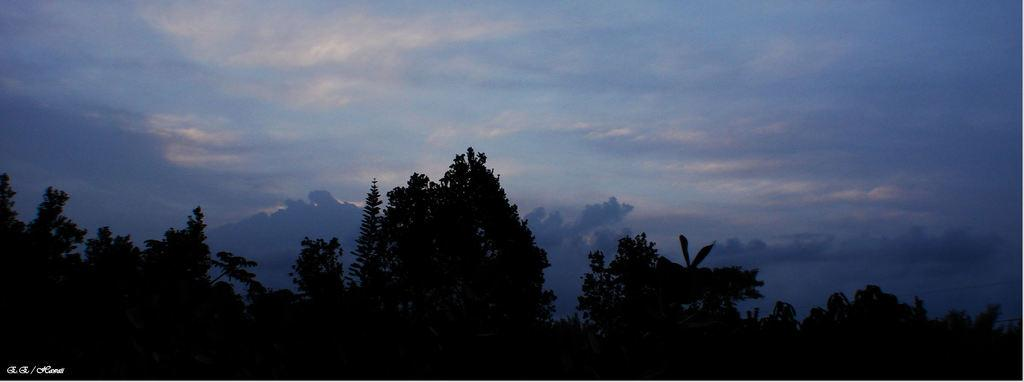What type of vegetation can be seen in the image? There is a group of trees in the image. What is the condition of the sky in the image? The sky is cloudy in the image. What type of theory is being discussed by the friends in the image? There are no people, let alone friends, present in the image, so there is no discussion or theory being discussed. 